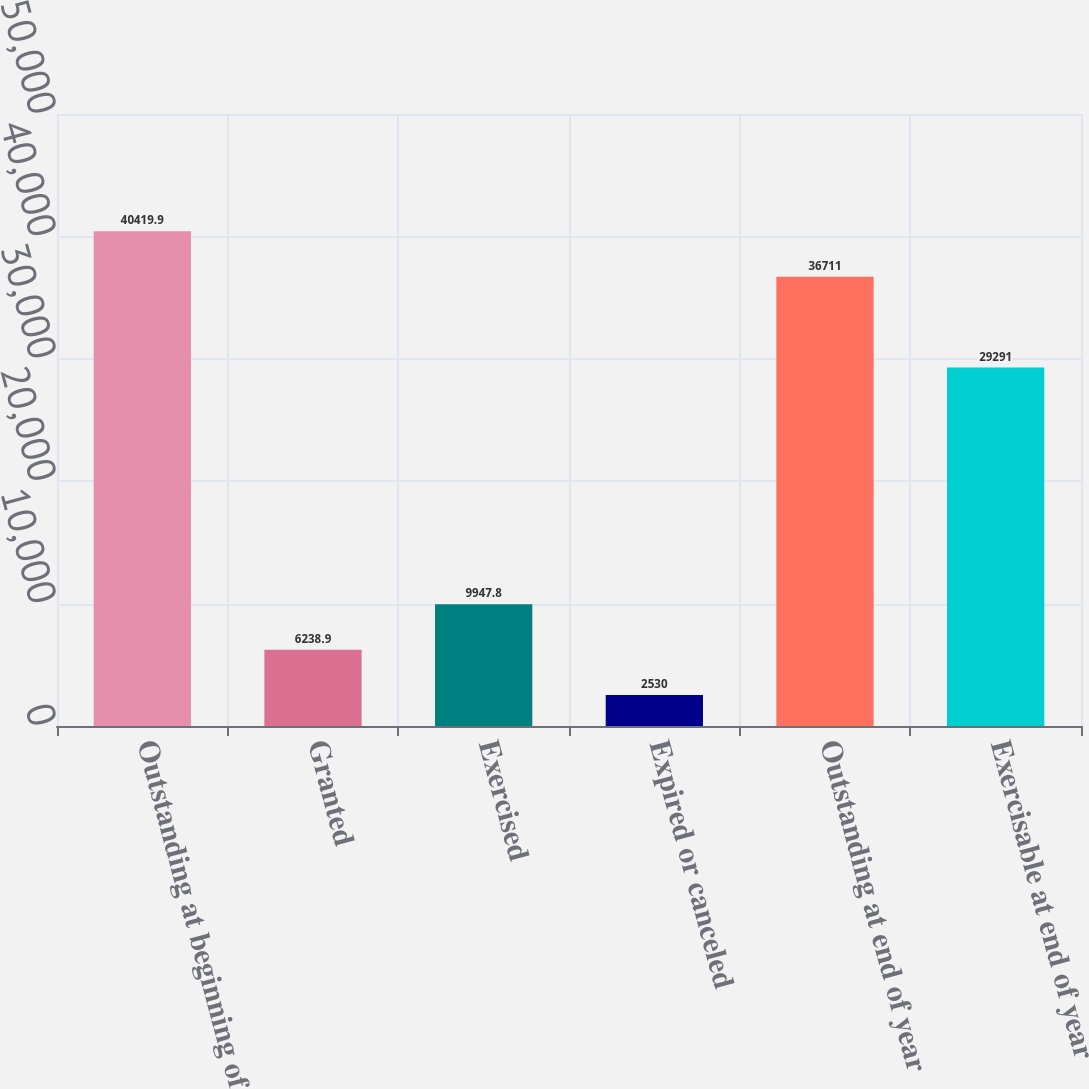Convert chart to OTSL. <chart><loc_0><loc_0><loc_500><loc_500><bar_chart><fcel>Outstanding at beginning of<fcel>Granted<fcel>Exercised<fcel>Expired or canceled<fcel>Outstanding at end of year<fcel>Exercisable at end of year<nl><fcel>40419.9<fcel>6238.9<fcel>9947.8<fcel>2530<fcel>36711<fcel>29291<nl></chart> 